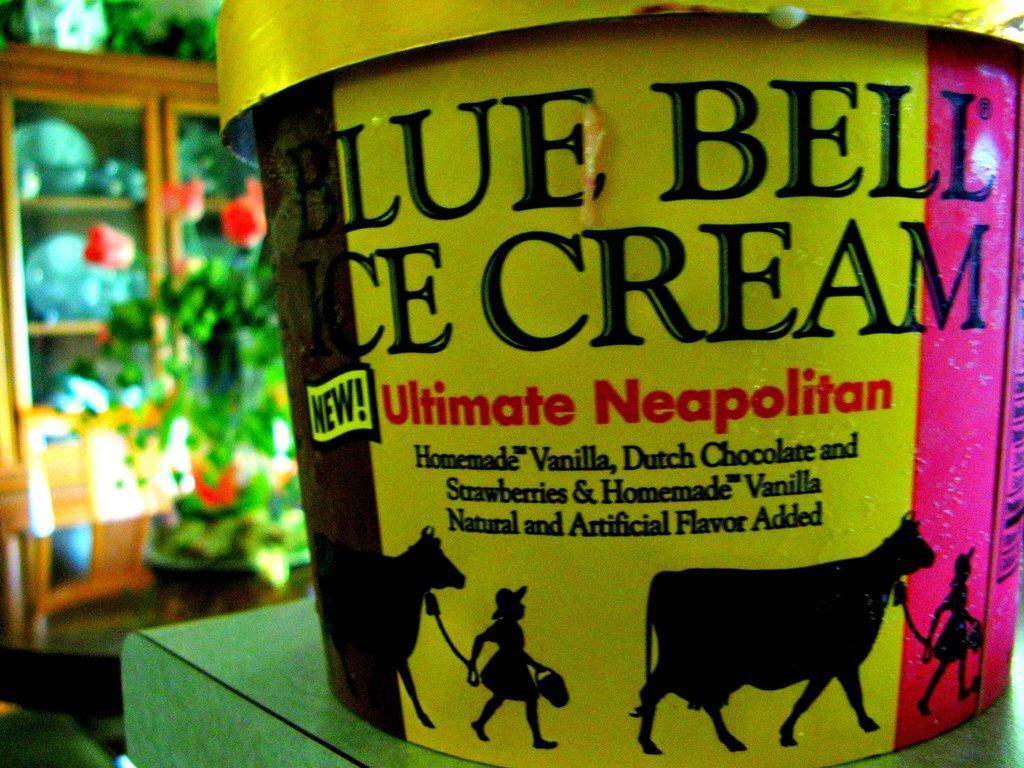Can you describe this image briefly? In this image in the foreground there is one bucket, and in the background there are some flower pots, baskets and one cupboard. In that cupboard there are some plates. 